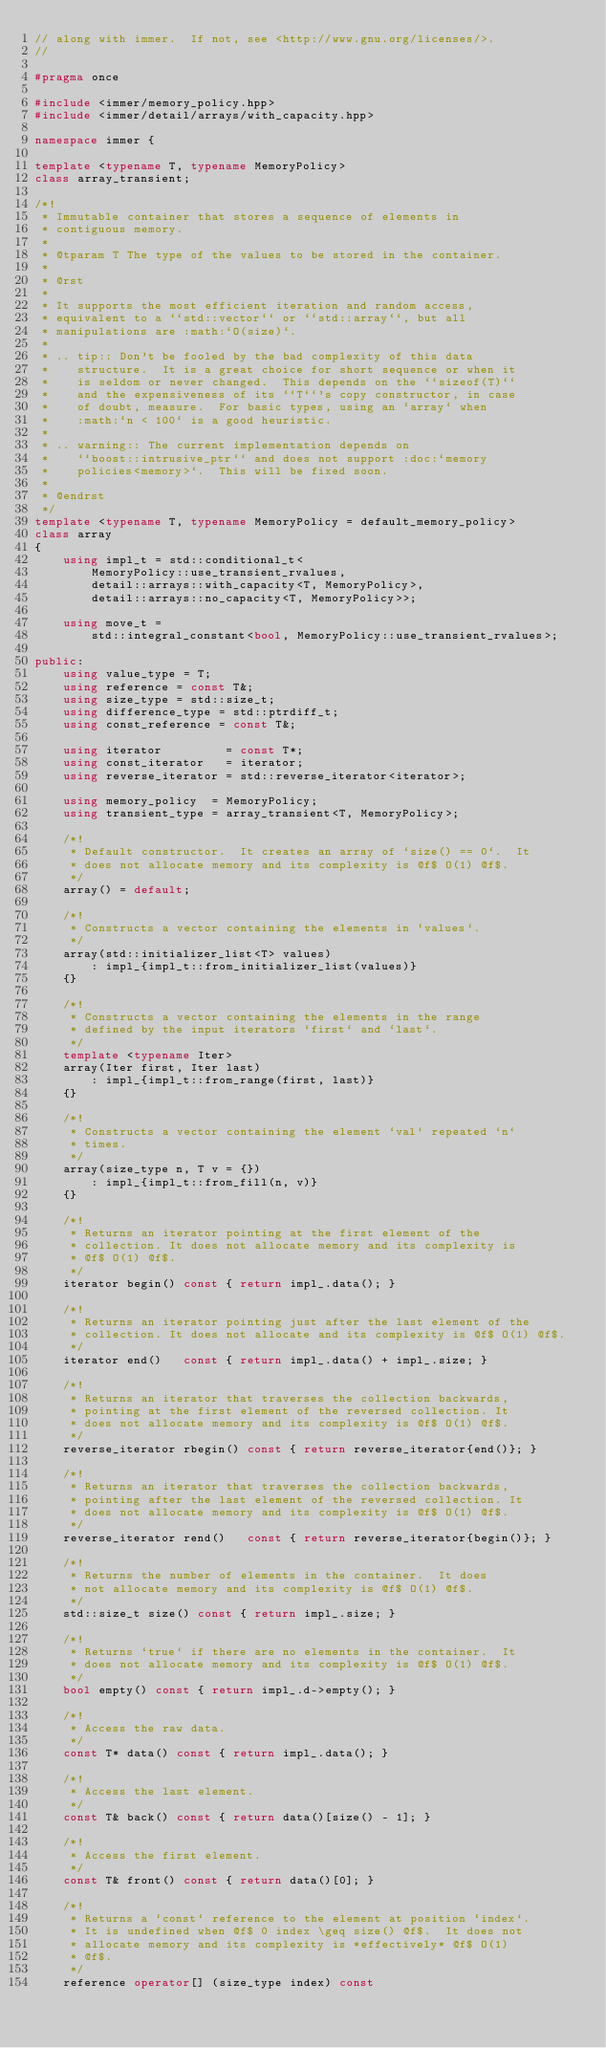<code> <loc_0><loc_0><loc_500><loc_500><_C++_>// along with immer.  If not, see <http://www.gnu.org/licenses/>.
//

#pragma once

#include <immer/memory_policy.hpp>
#include <immer/detail/arrays/with_capacity.hpp>

namespace immer {

template <typename T, typename MemoryPolicy>
class array_transient;

/*!
 * Immutable container that stores a sequence of elements in
 * contiguous memory.
 *
 * @tparam T The type of the values to be stored in the container.
 *
 * @rst
 *
 * It supports the most efficient iteration and random access,
 * equivalent to a ``std::vector`` or ``std::array``, but all
 * manipulations are :math:`O(size)`.
 *
 * .. tip:: Don't be fooled by the bad complexity of this data
 *    structure.  It is a great choice for short sequence or when it
 *    is seldom or never changed.  This depends on the ``sizeof(T)``
 *    and the expensiveness of its ``T``'s copy constructor, in case
 *    of doubt, measure.  For basic types, using an `array` when
 *    :math:`n < 100` is a good heuristic.
 *
 * .. warning:: The current implementation depends on
 *    ``boost::intrusive_ptr`` and does not support :doc:`memory
 *    policies<memory>`.  This will be fixed soon.
 *
 * @endrst
 */
template <typename T, typename MemoryPolicy = default_memory_policy>
class array
{
    using impl_t = std::conditional_t<
        MemoryPolicy::use_transient_rvalues,
        detail::arrays::with_capacity<T, MemoryPolicy>,
        detail::arrays::no_capacity<T, MemoryPolicy>>;

    using move_t =
        std::integral_constant<bool, MemoryPolicy::use_transient_rvalues>;

public:
    using value_type = T;
    using reference = const T&;
    using size_type = std::size_t;
    using difference_type = std::ptrdiff_t;
    using const_reference = const T&;

    using iterator         = const T*;
    using const_iterator   = iterator;
    using reverse_iterator = std::reverse_iterator<iterator>;

    using memory_policy  = MemoryPolicy;
    using transient_type = array_transient<T, MemoryPolicy>;

    /*!
     * Default constructor.  It creates an array of `size() == 0`.  It
     * does not allocate memory and its complexity is @f$ O(1) @f$.
     */
    array() = default;

    /*!
     * Constructs a vector containing the elements in `values`.
     */
    array(std::initializer_list<T> values)
        : impl_{impl_t::from_initializer_list(values)}
    {}

    /*!
     * Constructs a vector containing the elements in the range
     * defined by the input iterators `first` and `last`.
     */
    template <typename Iter>
    array(Iter first, Iter last)
        : impl_{impl_t::from_range(first, last)}
    {}

    /*!
     * Constructs a vector containing the element `val` repeated `n`
     * times.
     */
    array(size_type n, T v = {})
        : impl_{impl_t::from_fill(n, v)}
    {}

    /*!
     * Returns an iterator pointing at the first element of the
     * collection. It does not allocate memory and its complexity is
     * @f$ O(1) @f$.
     */
    iterator begin() const { return impl_.data(); }

    /*!
     * Returns an iterator pointing just after the last element of the
     * collection. It does not allocate and its complexity is @f$ O(1) @f$.
     */
    iterator end()   const { return impl_.data() + impl_.size; }

    /*!
     * Returns an iterator that traverses the collection backwards,
     * pointing at the first element of the reversed collection. It
     * does not allocate memory and its complexity is @f$ O(1) @f$.
     */
    reverse_iterator rbegin() const { return reverse_iterator{end()}; }

    /*!
     * Returns an iterator that traverses the collection backwards,
     * pointing after the last element of the reversed collection. It
     * does not allocate memory and its complexity is @f$ O(1) @f$.
     */
    reverse_iterator rend()   const { return reverse_iterator{begin()}; }

    /*!
     * Returns the number of elements in the container.  It does
     * not allocate memory and its complexity is @f$ O(1) @f$.
     */
    std::size_t size() const { return impl_.size; }

    /*!
     * Returns `true` if there are no elements in the container.  It
     * does not allocate memory and its complexity is @f$ O(1) @f$.
     */
    bool empty() const { return impl_.d->empty(); }

    /*!
     * Access the raw data.
     */
    const T* data() const { return impl_.data(); }

    /*!
     * Access the last element.
     */
    const T& back() const { return data()[size() - 1]; }

    /*!
     * Access the first element.
     */
    const T& front() const { return data()[0]; }

    /*!
     * Returns a `const` reference to the element at position `index`.
     * It is undefined when @f$ 0 index \geq size() @f$.  It does not
     * allocate memory and its complexity is *effectively* @f$ O(1)
     * @f$.
     */
    reference operator[] (size_type index) const</code> 